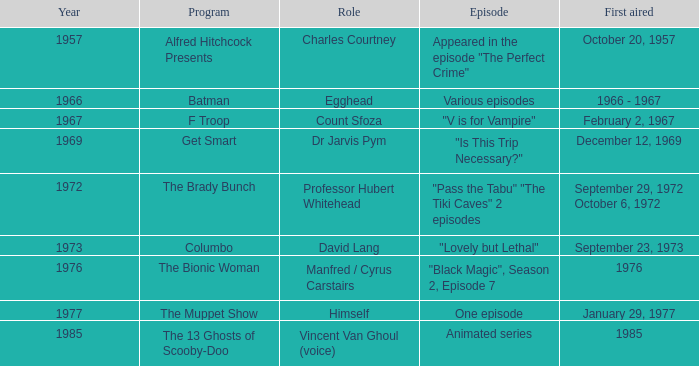Can you identify the batman episode? Various episodes. 